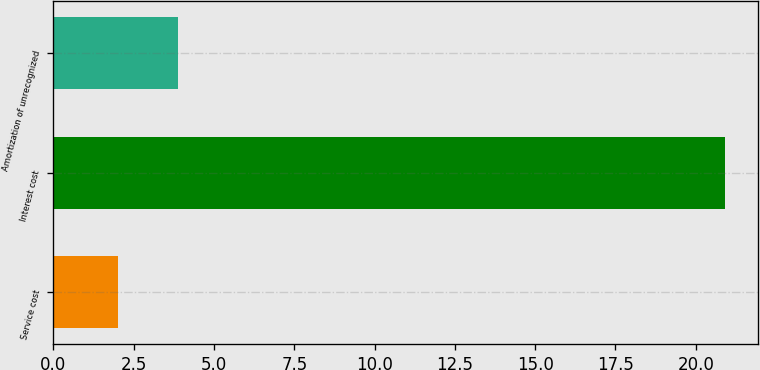Convert chart to OTSL. <chart><loc_0><loc_0><loc_500><loc_500><bar_chart><fcel>Service cost<fcel>Interest cost<fcel>Amortization of unrecognized<nl><fcel>2<fcel>20.9<fcel>3.89<nl></chart> 